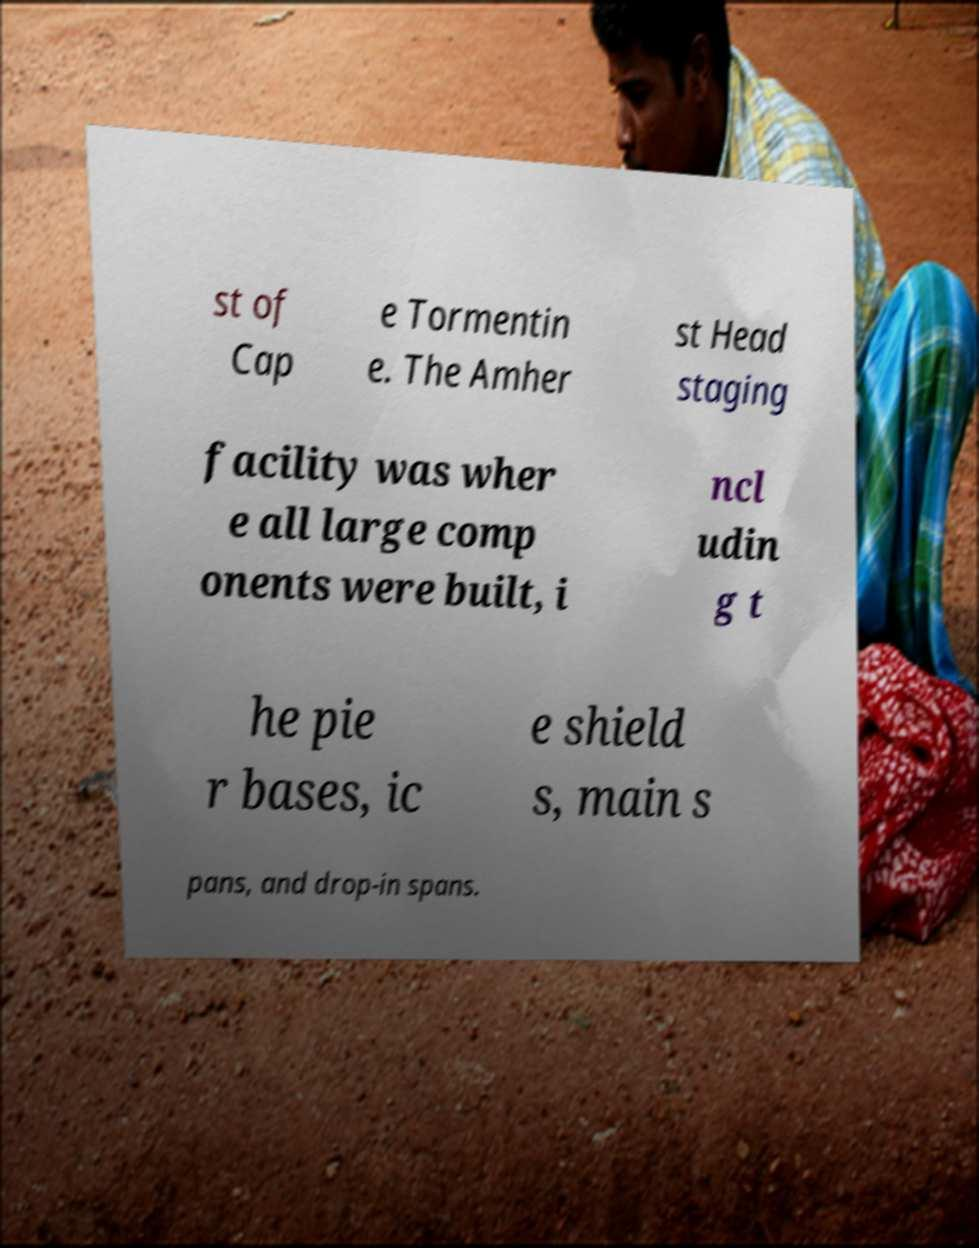Please identify and transcribe the text found in this image. st of Cap e Tormentin e. The Amher st Head staging facility was wher e all large comp onents were built, i ncl udin g t he pie r bases, ic e shield s, main s pans, and drop-in spans. 